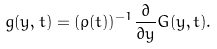Convert formula to latex. <formula><loc_0><loc_0><loc_500><loc_500>g ( y , t ) = ( \rho ( t ) ) ^ { - 1 } \frac { \partial } { \partial y } G ( y , t ) .</formula> 